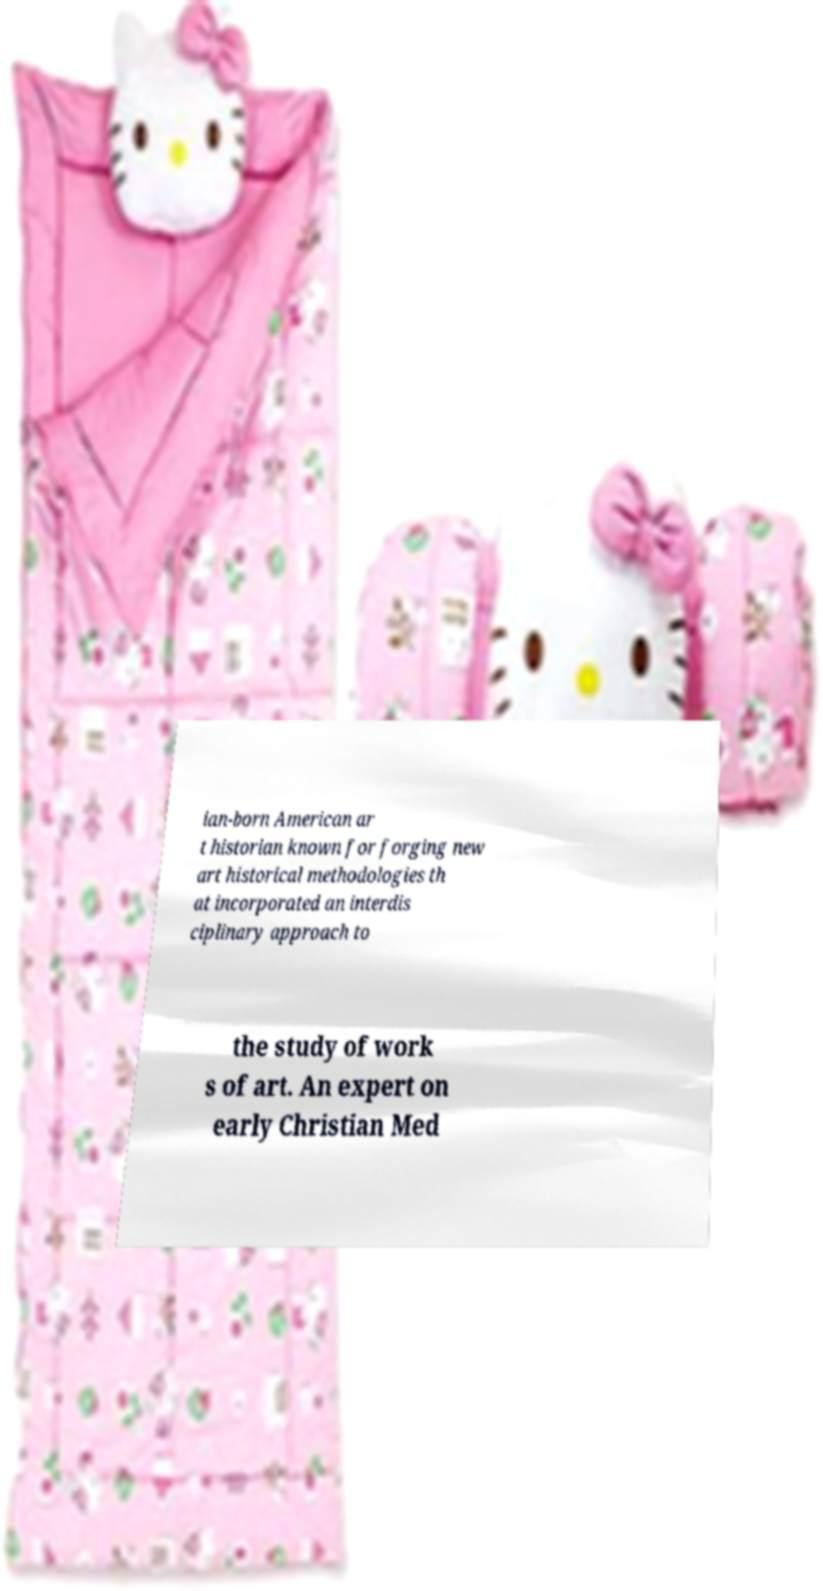There's text embedded in this image that I need extracted. Can you transcribe it verbatim? ian-born American ar t historian known for forging new art historical methodologies th at incorporated an interdis ciplinary approach to the study of work s of art. An expert on early Christian Med 